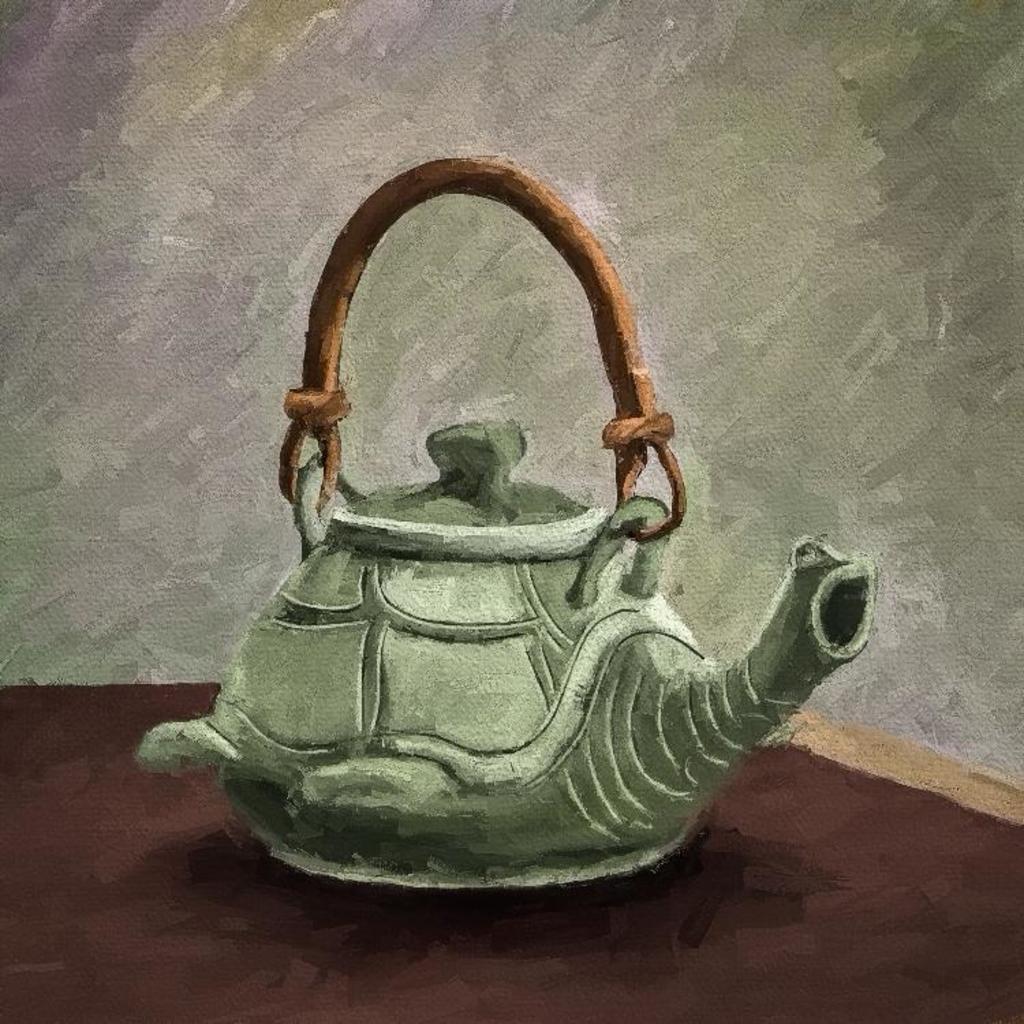In one or two sentences, can you explain what this image depicts? As we can see in the image there is painting of coffee cattle. 